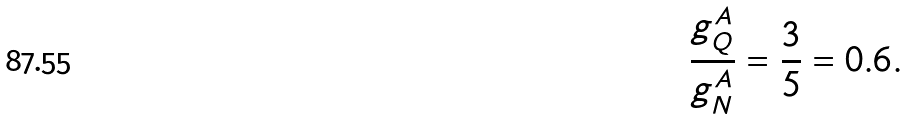<formula> <loc_0><loc_0><loc_500><loc_500>\frac { g _ { Q } ^ { A } } { g _ { N } ^ { A } } = \frac { 3 } { 5 } = 0 . 6 .</formula> 